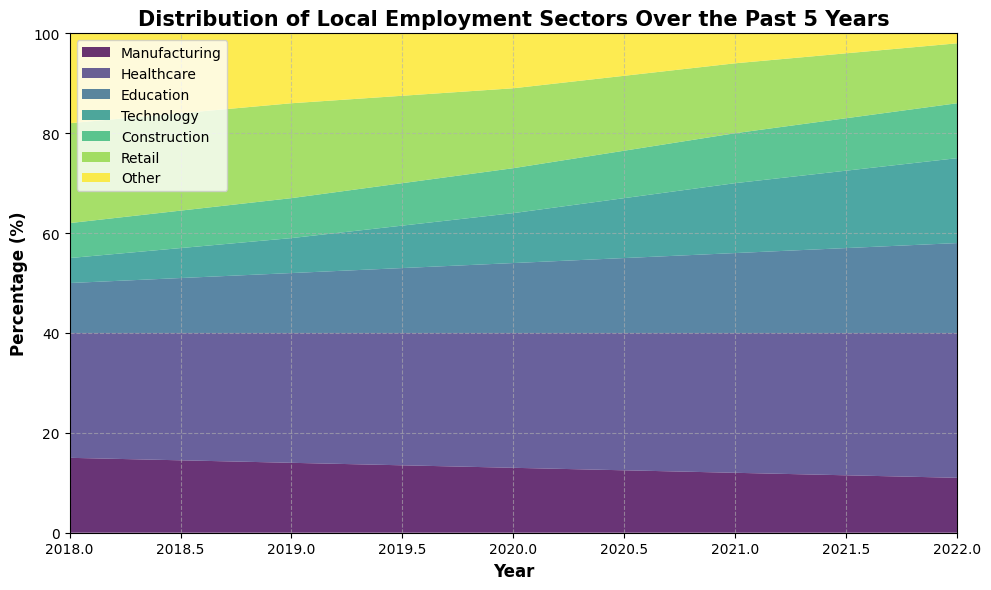Which employment sector had the highest percentage in 2022? To answer this, look at the right-most edge of the area chart (year 2022) and identify the sector covering the largest area.
Answer: Healthcare How did the percentage of Manufacturing change from 2018 to 2022? Identify the Manufacturing section on the left edge (2018) and compare it to the right edge (2022). The area representing Manufacturing decreased from 15% to 11%.
Answer: Decreased by 4% What's the difference between the percentages of the Healthcare and Technology sectors in 2022? For 2022, Healthcare is at 29% and Technology is at 17%. The difference is 29% - 17%.
Answer: 12% Which sector had a declining trend over the past 5 years? Observe the chart for sectors consistently decreasing in area from 2018 to 2022. Manufacturing is the sector that shows a steady decline.
Answer: Manufacturing What is the combined percentage of Education and Technology sectors in 2020? For 2020, Education is 14% and Technology is 10%. The combined percentage is 14% + 10%.
Answer: 24% Which sector saw the highest increase in percentage from 2018 to 2022? For each sector, calculate the difference between the percentage in 2018 and 2022. Healthcare increased from 25% to 29%, which is the highest increase.
Answer: Healthcare Were there any sectors not present in 2022? Examine the area chart for 2022 to see if any sectors have an area of 0%. The 'Other' sector was at 2%, indicating that all sectors were present.
Answer: No How did the proportion of Retail sector change from 2019 to 2021? Compare the area for Retail in 2019 (19%) and 2021 (14%). The proportion decreased by 19% - 14%.
Answer: Decreased by 5% What year did the Technology sector first surpass 10%? Check for the earliest year where the Technology sector exceeds 10%. The chart shows it was in 2020.
Answer: 2020 Compare the total percentage of Manufacturing and Construction sectors in 2018. Which is higher? In 2018, Manufacturing is 15% and Construction is 7%. Compare 15% and 7%, Manufacturing is higher.
Answer: Manufacturing 